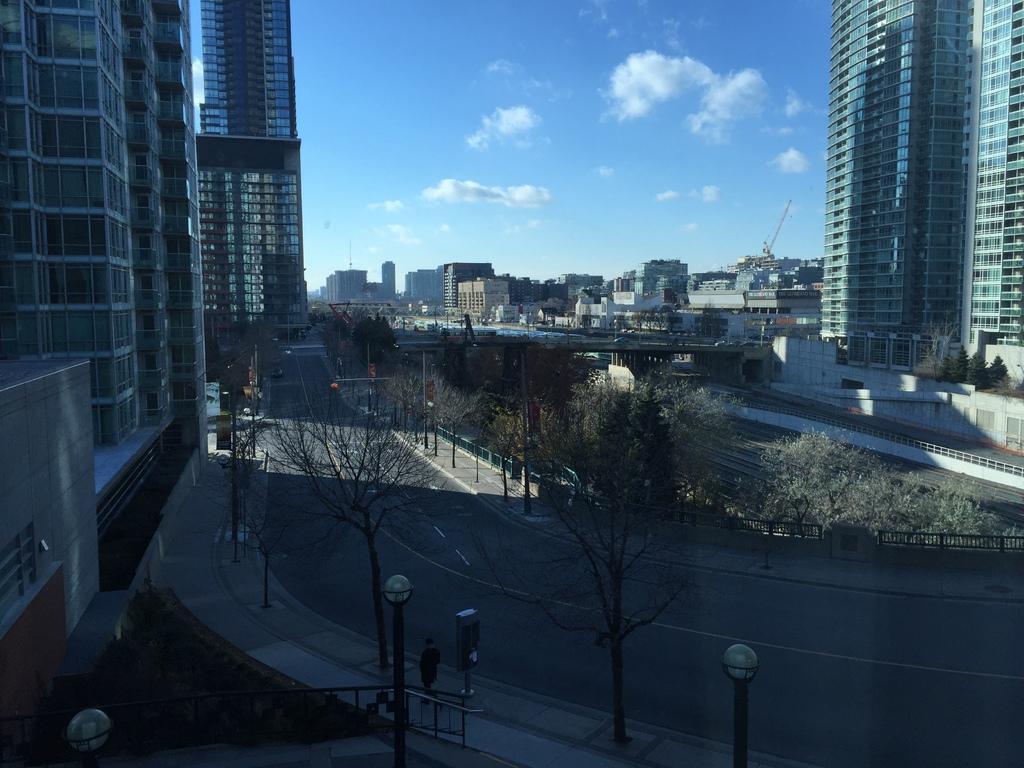Describe this image in one or two sentences. In this image, we can see buildings, bridge, roads, trees, plants, railings, lights, vehicles and few objects. Here we can see a person on the walkway. Background there is the sky. 